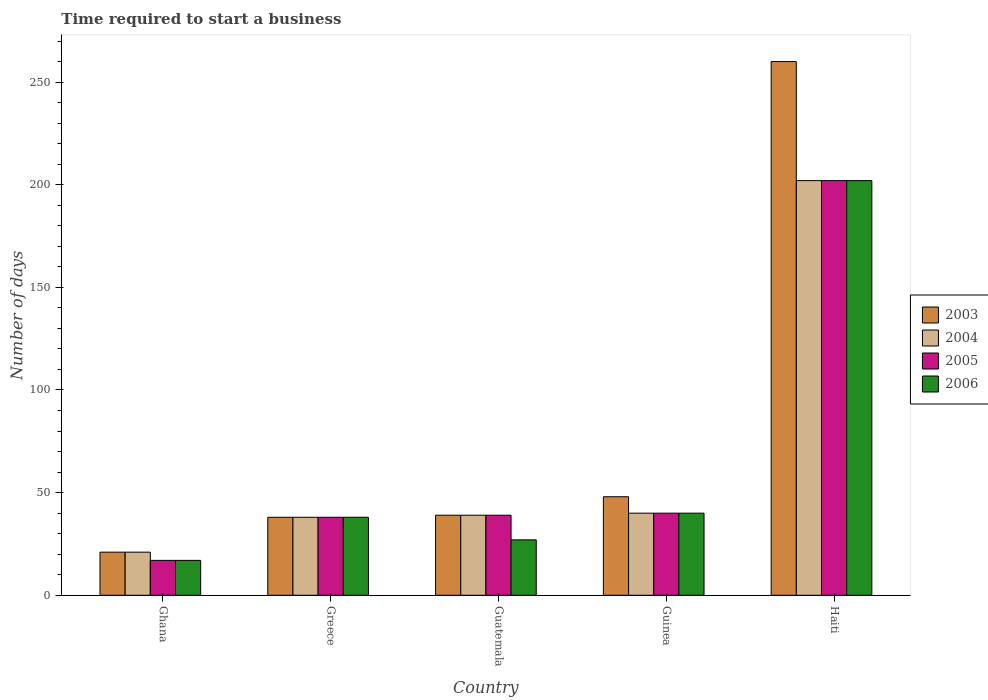How many different coloured bars are there?
Your answer should be very brief. 4. Are the number of bars per tick equal to the number of legend labels?
Give a very brief answer. Yes. Are the number of bars on each tick of the X-axis equal?
Your answer should be very brief. Yes. How many bars are there on the 1st tick from the left?
Provide a succinct answer. 4. What is the label of the 2nd group of bars from the left?
Ensure brevity in your answer.  Greece. Across all countries, what is the maximum number of days required to start a business in 2003?
Give a very brief answer. 260. In which country was the number of days required to start a business in 2005 maximum?
Offer a terse response. Haiti. In which country was the number of days required to start a business in 2005 minimum?
Provide a short and direct response. Ghana. What is the total number of days required to start a business in 2005 in the graph?
Offer a very short reply. 336. What is the difference between the number of days required to start a business in 2003 in Ghana and that in Haiti?
Offer a terse response. -239. What is the difference between the number of days required to start a business in 2003 in Guinea and the number of days required to start a business in 2004 in Ghana?
Offer a very short reply. 27. What is the average number of days required to start a business in 2005 per country?
Your answer should be very brief. 67.2. What is the difference between the number of days required to start a business of/in 2005 and number of days required to start a business of/in 2006 in Guinea?
Your response must be concise. 0. What is the ratio of the number of days required to start a business in 2006 in Greece to that in Haiti?
Make the answer very short. 0.19. Is the number of days required to start a business in 2005 in Greece less than that in Guinea?
Keep it short and to the point. Yes. What is the difference between the highest and the second highest number of days required to start a business in 2006?
Keep it short and to the point. -162. What is the difference between the highest and the lowest number of days required to start a business in 2005?
Your answer should be very brief. 185. Is the sum of the number of days required to start a business in 2003 in Ghana and Haiti greater than the maximum number of days required to start a business in 2004 across all countries?
Give a very brief answer. Yes. Is it the case that in every country, the sum of the number of days required to start a business in 2006 and number of days required to start a business in 2005 is greater than the sum of number of days required to start a business in 2003 and number of days required to start a business in 2004?
Give a very brief answer. No. What does the 3rd bar from the left in Greece represents?
Your answer should be very brief. 2005. What does the 4th bar from the right in Guatemala represents?
Keep it short and to the point. 2003. How many bars are there?
Ensure brevity in your answer.  20. Are all the bars in the graph horizontal?
Ensure brevity in your answer.  No. How many countries are there in the graph?
Provide a short and direct response. 5. Are the values on the major ticks of Y-axis written in scientific E-notation?
Offer a terse response. No. Does the graph contain any zero values?
Your answer should be very brief. No. What is the title of the graph?
Your answer should be compact. Time required to start a business. What is the label or title of the Y-axis?
Provide a succinct answer. Number of days. What is the Number of days in 2006 in Ghana?
Give a very brief answer. 17. What is the Number of days of 2006 in Greece?
Your response must be concise. 38. What is the Number of days in 2005 in Guatemala?
Your answer should be compact. 39. What is the Number of days of 2004 in Guinea?
Offer a terse response. 40. What is the Number of days in 2006 in Guinea?
Keep it short and to the point. 40. What is the Number of days in 2003 in Haiti?
Provide a short and direct response. 260. What is the Number of days of 2004 in Haiti?
Offer a terse response. 202. What is the Number of days of 2005 in Haiti?
Your response must be concise. 202. What is the Number of days in 2006 in Haiti?
Your answer should be compact. 202. Across all countries, what is the maximum Number of days of 2003?
Provide a short and direct response. 260. Across all countries, what is the maximum Number of days in 2004?
Give a very brief answer. 202. Across all countries, what is the maximum Number of days in 2005?
Make the answer very short. 202. Across all countries, what is the maximum Number of days of 2006?
Offer a terse response. 202. Across all countries, what is the minimum Number of days of 2004?
Provide a short and direct response. 21. Across all countries, what is the minimum Number of days in 2005?
Provide a succinct answer. 17. Across all countries, what is the minimum Number of days of 2006?
Make the answer very short. 17. What is the total Number of days of 2003 in the graph?
Make the answer very short. 406. What is the total Number of days in 2004 in the graph?
Keep it short and to the point. 340. What is the total Number of days of 2005 in the graph?
Your response must be concise. 336. What is the total Number of days of 2006 in the graph?
Your answer should be compact. 324. What is the difference between the Number of days in 2004 in Ghana and that in Greece?
Provide a succinct answer. -17. What is the difference between the Number of days in 2005 in Ghana and that in Greece?
Keep it short and to the point. -21. What is the difference between the Number of days of 2004 in Ghana and that in Guatemala?
Offer a very short reply. -18. What is the difference between the Number of days of 2005 in Ghana and that in Guatemala?
Offer a very short reply. -22. What is the difference between the Number of days in 2004 in Ghana and that in Guinea?
Your answer should be very brief. -19. What is the difference between the Number of days of 2005 in Ghana and that in Guinea?
Provide a short and direct response. -23. What is the difference between the Number of days in 2006 in Ghana and that in Guinea?
Provide a succinct answer. -23. What is the difference between the Number of days of 2003 in Ghana and that in Haiti?
Keep it short and to the point. -239. What is the difference between the Number of days of 2004 in Ghana and that in Haiti?
Offer a terse response. -181. What is the difference between the Number of days of 2005 in Ghana and that in Haiti?
Your answer should be very brief. -185. What is the difference between the Number of days of 2006 in Ghana and that in Haiti?
Offer a terse response. -185. What is the difference between the Number of days in 2005 in Greece and that in Guatemala?
Provide a succinct answer. -1. What is the difference between the Number of days of 2006 in Greece and that in Guatemala?
Your answer should be compact. 11. What is the difference between the Number of days of 2003 in Greece and that in Guinea?
Make the answer very short. -10. What is the difference between the Number of days of 2006 in Greece and that in Guinea?
Provide a succinct answer. -2. What is the difference between the Number of days in 2003 in Greece and that in Haiti?
Your answer should be very brief. -222. What is the difference between the Number of days of 2004 in Greece and that in Haiti?
Ensure brevity in your answer.  -164. What is the difference between the Number of days in 2005 in Greece and that in Haiti?
Provide a short and direct response. -164. What is the difference between the Number of days of 2006 in Greece and that in Haiti?
Your response must be concise. -164. What is the difference between the Number of days in 2004 in Guatemala and that in Guinea?
Offer a very short reply. -1. What is the difference between the Number of days in 2006 in Guatemala and that in Guinea?
Your answer should be compact. -13. What is the difference between the Number of days in 2003 in Guatemala and that in Haiti?
Ensure brevity in your answer.  -221. What is the difference between the Number of days in 2004 in Guatemala and that in Haiti?
Keep it short and to the point. -163. What is the difference between the Number of days in 2005 in Guatemala and that in Haiti?
Offer a terse response. -163. What is the difference between the Number of days of 2006 in Guatemala and that in Haiti?
Make the answer very short. -175. What is the difference between the Number of days of 2003 in Guinea and that in Haiti?
Your answer should be very brief. -212. What is the difference between the Number of days in 2004 in Guinea and that in Haiti?
Keep it short and to the point. -162. What is the difference between the Number of days in 2005 in Guinea and that in Haiti?
Keep it short and to the point. -162. What is the difference between the Number of days in 2006 in Guinea and that in Haiti?
Provide a succinct answer. -162. What is the difference between the Number of days of 2003 in Ghana and the Number of days of 2004 in Greece?
Provide a succinct answer. -17. What is the difference between the Number of days of 2003 in Ghana and the Number of days of 2006 in Greece?
Offer a terse response. -17. What is the difference between the Number of days in 2004 in Ghana and the Number of days in 2005 in Greece?
Ensure brevity in your answer.  -17. What is the difference between the Number of days in 2003 in Ghana and the Number of days in 2004 in Guatemala?
Provide a short and direct response. -18. What is the difference between the Number of days in 2004 in Ghana and the Number of days in 2005 in Guatemala?
Your response must be concise. -18. What is the difference between the Number of days of 2003 in Ghana and the Number of days of 2004 in Guinea?
Provide a succinct answer. -19. What is the difference between the Number of days in 2003 in Ghana and the Number of days in 2006 in Guinea?
Your response must be concise. -19. What is the difference between the Number of days of 2004 in Ghana and the Number of days of 2005 in Guinea?
Your answer should be very brief. -19. What is the difference between the Number of days in 2004 in Ghana and the Number of days in 2006 in Guinea?
Keep it short and to the point. -19. What is the difference between the Number of days in 2003 in Ghana and the Number of days in 2004 in Haiti?
Your answer should be very brief. -181. What is the difference between the Number of days of 2003 in Ghana and the Number of days of 2005 in Haiti?
Your response must be concise. -181. What is the difference between the Number of days of 2003 in Ghana and the Number of days of 2006 in Haiti?
Keep it short and to the point. -181. What is the difference between the Number of days of 2004 in Ghana and the Number of days of 2005 in Haiti?
Your response must be concise. -181. What is the difference between the Number of days in 2004 in Ghana and the Number of days in 2006 in Haiti?
Offer a terse response. -181. What is the difference between the Number of days in 2005 in Ghana and the Number of days in 2006 in Haiti?
Your answer should be compact. -185. What is the difference between the Number of days in 2003 in Greece and the Number of days in 2005 in Guatemala?
Provide a succinct answer. -1. What is the difference between the Number of days of 2004 in Greece and the Number of days of 2005 in Guatemala?
Provide a succinct answer. -1. What is the difference between the Number of days in 2004 in Greece and the Number of days in 2006 in Guatemala?
Make the answer very short. 11. What is the difference between the Number of days of 2003 in Greece and the Number of days of 2005 in Guinea?
Give a very brief answer. -2. What is the difference between the Number of days in 2003 in Greece and the Number of days in 2006 in Guinea?
Make the answer very short. -2. What is the difference between the Number of days of 2004 in Greece and the Number of days of 2006 in Guinea?
Ensure brevity in your answer.  -2. What is the difference between the Number of days in 2005 in Greece and the Number of days in 2006 in Guinea?
Make the answer very short. -2. What is the difference between the Number of days in 2003 in Greece and the Number of days in 2004 in Haiti?
Your answer should be very brief. -164. What is the difference between the Number of days of 2003 in Greece and the Number of days of 2005 in Haiti?
Ensure brevity in your answer.  -164. What is the difference between the Number of days of 2003 in Greece and the Number of days of 2006 in Haiti?
Keep it short and to the point. -164. What is the difference between the Number of days of 2004 in Greece and the Number of days of 2005 in Haiti?
Make the answer very short. -164. What is the difference between the Number of days in 2004 in Greece and the Number of days in 2006 in Haiti?
Your answer should be compact. -164. What is the difference between the Number of days of 2005 in Greece and the Number of days of 2006 in Haiti?
Your answer should be compact. -164. What is the difference between the Number of days in 2003 in Guatemala and the Number of days in 2005 in Guinea?
Your response must be concise. -1. What is the difference between the Number of days of 2003 in Guatemala and the Number of days of 2006 in Guinea?
Ensure brevity in your answer.  -1. What is the difference between the Number of days in 2004 in Guatemala and the Number of days in 2006 in Guinea?
Keep it short and to the point. -1. What is the difference between the Number of days in 2003 in Guatemala and the Number of days in 2004 in Haiti?
Your answer should be very brief. -163. What is the difference between the Number of days of 2003 in Guatemala and the Number of days of 2005 in Haiti?
Keep it short and to the point. -163. What is the difference between the Number of days of 2003 in Guatemala and the Number of days of 2006 in Haiti?
Offer a terse response. -163. What is the difference between the Number of days in 2004 in Guatemala and the Number of days in 2005 in Haiti?
Your response must be concise. -163. What is the difference between the Number of days in 2004 in Guatemala and the Number of days in 2006 in Haiti?
Your response must be concise. -163. What is the difference between the Number of days of 2005 in Guatemala and the Number of days of 2006 in Haiti?
Your answer should be very brief. -163. What is the difference between the Number of days of 2003 in Guinea and the Number of days of 2004 in Haiti?
Your answer should be very brief. -154. What is the difference between the Number of days of 2003 in Guinea and the Number of days of 2005 in Haiti?
Make the answer very short. -154. What is the difference between the Number of days of 2003 in Guinea and the Number of days of 2006 in Haiti?
Make the answer very short. -154. What is the difference between the Number of days of 2004 in Guinea and the Number of days of 2005 in Haiti?
Offer a terse response. -162. What is the difference between the Number of days of 2004 in Guinea and the Number of days of 2006 in Haiti?
Offer a very short reply. -162. What is the difference between the Number of days of 2005 in Guinea and the Number of days of 2006 in Haiti?
Offer a very short reply. -162. What is the average Number of days of 2003 per country?
Your answer should be compact. 81.2. What is the average Number of days in 2005 per country?
Offer a very short reply. 67.2. What is the average Number of days of 2006 per country?
Your response must be concise. 64.8. What is the difference between the Number of days in 2003 and Number of days in 2004 in Ghana?
Provide a succinct answer. 0. What is the difference between the Number of days in 2003 and Number of days in 2006 in Ghana?
Provide a succinct answer. 4. What is the difference between the Number of days of 2004 and Number of days of 2006 in Ghana?
Ensure brevity in your answer.  4. What is the difference between the Number of days in 2003 and Number of days in 2005 in Greece?
Keep it short and to the point. 0. What is the difference between the Number of days in 2004 and Number of days in 2005 in Greece?
Your answer should be very brief. 0. What is the difference between the Number of days in 2004 and Number of days in 2006 in Greece?
Provide a succinct answer. 0. What is the difference between the Number of days in 2003 and Number of days in 2004 in Guatemala?
Ensure brevity in your answer.  0. What is the difference between the Number of days of 2003 and Number of days of 2006 in Guatemala?
Your answer should be very brief. 12. What is the difference between the Number of days of 2004 and Number of days of 2005 in Guatemala?
Provide a succinct answer. 0. What is the difference between the Number of days in 2005 and Number of days in 2006 in Guatemala?
Your answer should be very brief. 12. What is the difference between the Number of days in 2003 and Number of days in 2004 in Guinea?
Your response must be concise. 8. What is the difference between the Number of days of 2005 and Number of days of 2006 in Guinea?
Offer a very short reply. 0. What is the difference between the Number of days in 2003 and Number of days in 2004 in Haiti?
Provide a succinct answer. 58. What is the difference between the Number of days of 2003 and Number of days of 2005 in Haiti?
Offer a very short reply. 58. What is the difference between the Number of days of 2003 and Number of days of 2006 in Haiti?
Give a very brief answer. 58. What is the difference between the Number of days in 2004 and Number of days in 2006 in Haiti?
Make the answer very short. 0. What is the difference between the Number of days in 2005 and Number of days in 2006 in Haiti?
Provide a succinct answer. 0. What is the ratio of the Number of days of 2003 in Ghana to that in Greece?
Ensure brevity in your answer.  0.55. What is the ratio of the Number of days of 2004 in Ghana to that in Greece?
Ensure brevity in your answer.  0.55. What is the ratio of the Number of days in 2005 in Ghana to that in Greece?
Your answer should be compact. 0.45. What is the ratio of the Number of days in 2006 in Ghana to that in Greece?
Give a very brief answer. 0.45. What is the ratio of the Number of days in 2003 in Ghana to that in Guatemala?
Make the answer very short. 0.54. What is the ratio of the Number of days of 2004 in Ghana to that in Guatemala?
Offer a very short reply. 0.54. What is the ratio of the Number of days of 2005 in Ghana to that in Guatemala?
Give a very brief answer. 0.44. What is the ratio of the Number of days of 2006 in Ghana to that in Guatemala?
Provide a short and direct response. 0.63. What is the ratio of the Number of days of 2003 in Ghana to that in Guinea?
Keep it short and to the point. 0.44. What is the ratio of the Number of days of 2004 in Ghana to that in Guinea?
Your answer should be compact. 0.53. What is the ratio of the Number of days in 2005 in Ghana to that in Guinea?
Give a very brief answer. 0.42. What is the ratio of the Number of days of 2006 in Ghana to that in Guinea?
Provide a succinct answer. 0.42. What is the ratio of the Number of days in 2003 in Ghana to that in Haiti?
Your response must be concise. 0.08. What is the ratio of the Number of days of 2004 in Ghana to that in Haiti?
Offer a very short reply. 0.1. What is the ratio of the Number of days in 2005 in Ghana to that in Haiti?
Your answer should be very brief. 0.08. What is the ratio of the Number of days of 2006 in Ghana to that in Haiti?
Offer a terse response. 0.08. What is the ratio of the Number of days of 2003 in Greece to that in Guatemala?
Make the answer very short. 0.97. What is the ratio of the Number of days of 2004 in Greece to that in Guatemala?
Give a very brief answer. 0.97. What is the ratio of the Number of days in 2005 in Greece to that in Guatemala?
Provide a succinct answer. 0.97. What is the ratio of the Number of days in 2006 in Greece to that in Guatemala?
Your answer should be compact. 1.41. What is the ratio of the Number of days in 2003 in Greece to that in Guinea?
Offer a terse response. 0.79. What is the ratio of the Number of days of 2004 in Greece to that in Guinea?
Make the answer very short. 0.95. What is the ratio of the Number of days of 2003 in Greece to that in Haiti?
Make the answer very short. 0.15. What is the ratio of the Number of days in 2004 in Greece to that in Haiti?
Provide a short and direct response. 0.19. What is the ratio of the Number of days of 2005 in Greece to that in Haiti?
Offer a terse response. 0.19. What is the ratio of the Number of days in 2006 in Greece to that in Haiti?
Offer a terse response. 0.19. What is the ratio of the Number of days in 2003 in Guatemala to that in Guinea?
Your answer should be very brief. 0.81. What is the ratio of the Number of days of 2004 in Guatemala to that in Guinea?
Make the answer very short. 0.97. What is the ratio of the Number of days of 2006 in Guatemala to that in Guinea?
Offer a very short reply. 0.68. What is the ratio of the Number of days of 2004 in Guatemala to that in Haiti?
Offer a very short reply. 0.19. What is the ratio of the Number of days of 2005 in Guatemala to that in Haiti?
Your response must be concise. 0.19. What is the ratio of the Number of days in 2006 in Guatemala to that in Haiti?
Offer a very short reply. 0.13. What is the ratio of the Number of days in 2003 in Guinea to that in Haiti?
Offer a very short reply. 0.18. What is the ratio of the Number of days of 2004 in Guinea to that in Haiti?
Ensure brevity in your answer.  0.2. What is the ratio of the Number of days in 2005 in Guinea to that in Haiti?
Ensure brevity in your answer.  0.2. What is the ratio of the Number of days in 2006 in Guinea to that in Haiti?
Provide a short and direct response. 0.2. What is the difference between the highest and the second highest Number of days of 2003?
Provide a short and direct response. 212. What is the difference between the highest and the second highest Number of days of 2004?
Give a very brief answer. 162. What is the difference between the highest and the second highest Number of days in 2005?
Provide a short and direct response. 162. What is the difference between the highest and the second highest Number of days in 2006?
Your answer should be very brief. 162. What is the difference between the highest and the lowest Number of days of 2003?
Make the answer very short. 239. What is the difference between the highest and the lowest Number of days in 2004?
Offer a terse response. 181. What is the difference between the highest and the lowest Number of days in 2005?
Keep it short and to the point. 185. What is the difference between the highest and the lowest Number of days in 2006?
Your answer should be very brief. 185. 